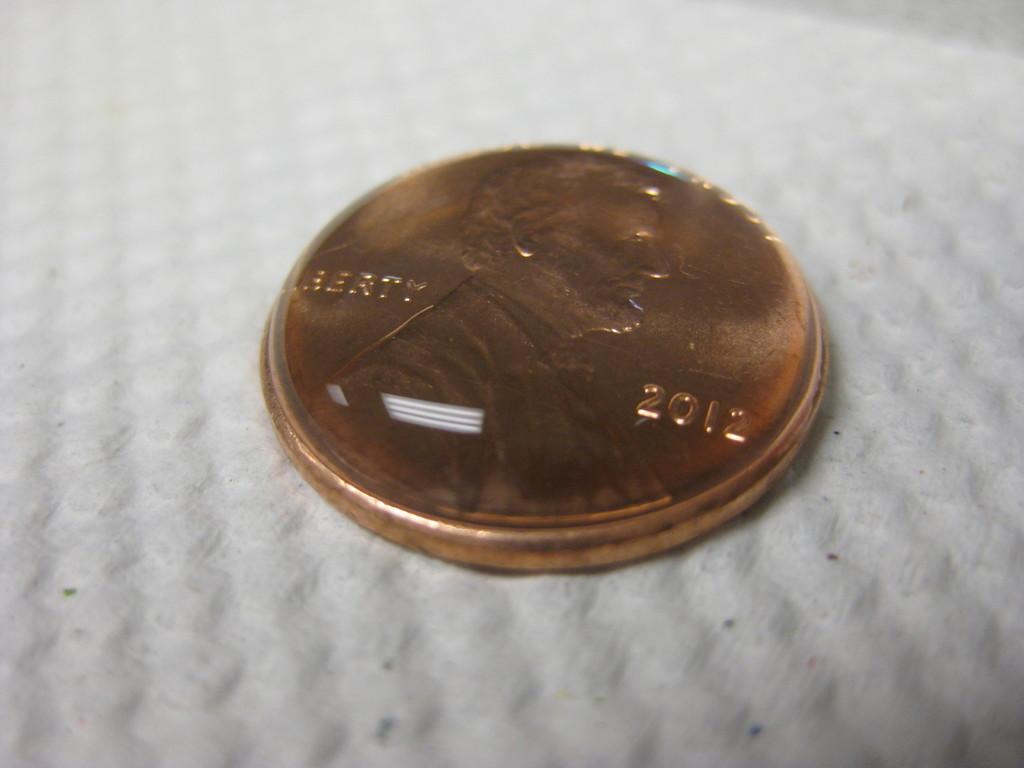What word is to the right of lincoln?
Provide a short and direct response. 2012. What year is the penny?
Provide a succinct answer. 2012. 